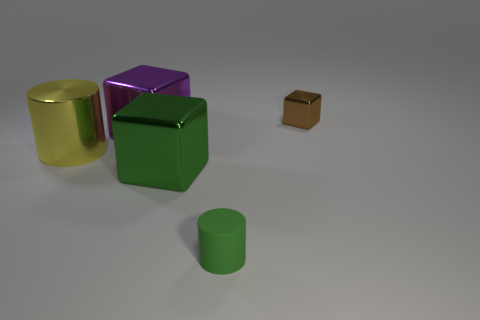Subtract all large green cubes. How many cubes are left? 2 Add 1 big cyan metallic cubes. How many objects exist? 6 Subtract all green cylinders. How many cylinders are left? 1 Subtract 1 cylinders. How many cylinders are left? 1 Subtract all blue cylinders. Subtract all cyan spheres. How many cylinders are left? 2 Subtract all purple cylinders. How many purple blocks are left? 1 Subtract all large metallic cubes. Subtract all large yellow metal cylinders. How many objects are left? 2 Add 1 large purple things. How many large purple things are left? 2 Add 1 big yellow things. How many big yellow things exist? 2 Subtract 0 gray cylinders. How many objects are left? 5 